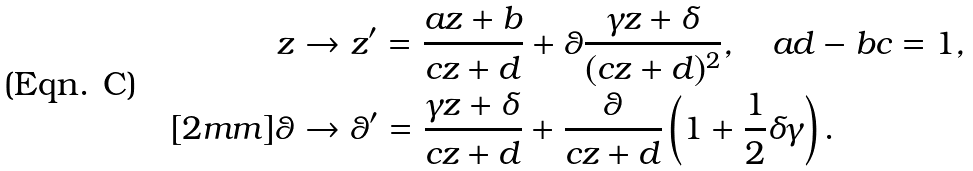<formula> <loc_0><loc_0><loc_500><loc_500>z & \to z ^ { \prime } = \frac { a z + b } { c z + d } + \theta \frac { \gamma z + \delta } { ( c z + d ) ^ { 2 } } , \quad a d - b c = 1 , \\ [ 2 m m ] \theta & \to \theta ^ { \prime } = \frac { \gamma z + \delta } { c z + d } + \frac { \theta } { c z + d } \left ( 1 + \frac { 1 } { 2 } \delta \gamma \right ) .</formula> 